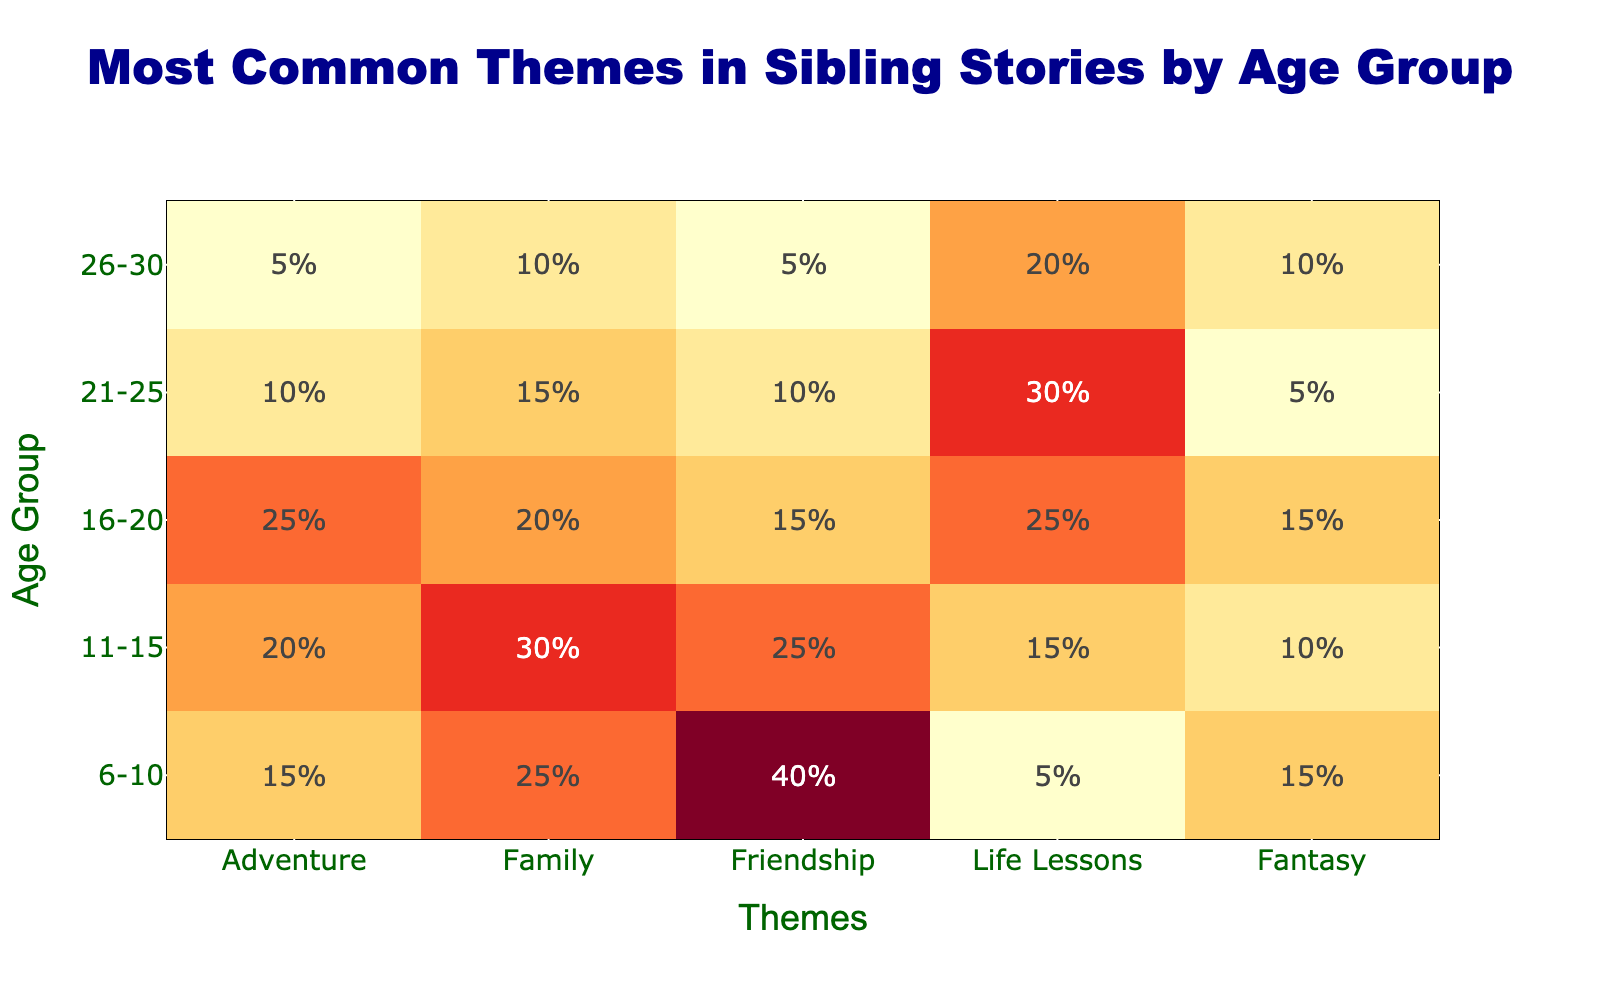What is the highest number of stories about Friendship in the age group 6-10? Looking at the column for Friendship in the age group 6-10, the value is 40.
Answer: 40 Which age group has the most stories about Life Lessons? The Life Lessons column values are as follows: 5 for 6-10, 15 for 11-15, 25 for 16-20, 30 for 21-25, and 20 for 26-30. The highest value is 30 in the 21-25 age group.
Answer: 21-25 True or False: The total number of stories about Adventure increases with age from 6-10 to 21-25. The Adventure values are: 15, 20, 25, 10, and 5 for age groups 6-10, 11-15, 16-20, 21-25, and 26-30 respectively. It does not consistently increase; it actually decreases after 16-20.
Answer: False What is the difference in the number of Fantasy stories between the 11-15 and 21-25 age groups? The value for Fantasy stories in the 11-15 age group is 10, while in the 21-25 age group it is 5. The difference is 10 - 5 = 5.
Answer: 5 What is the total number of stories across all themes for the age group 16-20? To find this, sum the values for the age group 16-20: 25 (Adventure) + 20 (Family) + 15 (Friendship) + 25 (Life Lessons) + 15 (Fantasy) = 100.
Answer: 100 Which theme has the lowest number of stories in the 26-30 age group? In the 26-30 age group, the values are: 5 (Adventure), 10 (Family), 5 (Friendship), 20 (Life Lessons), and 10 (Fantasy). Both Adventure and Friendship have the lowest value of 5.
Answer: Adventure and Friendship If you were to rank the age groups from highest to lowest in total number of stories for the theme Family, which would be the order? The numbers for Family are: 25 (6-10), 30 (11-15), 20 (16-20), 15 (21-25), and 10 (26-30). Ranking from highest to lowest, the order is 11-15, 6-10, 16-20, 21-25, 26-30.
Answer: 11-15, 6-10, 16-20, 21-25, 26-30 Which age group has a comparatively balanced number of stories across all themes? To determine this, we observe the rows for each age group. The 11-15 age group shows values all around 25-30 with no extreme highs or lows, indicating a balanced distribution.
Answer: 11-15 What age group has the largest variance in themes? The age group 6-10 shows a high count in Friendship (40) and a low in Life Lessons (5), indicating a larger variance in values between themes.
Answer: 6-10 